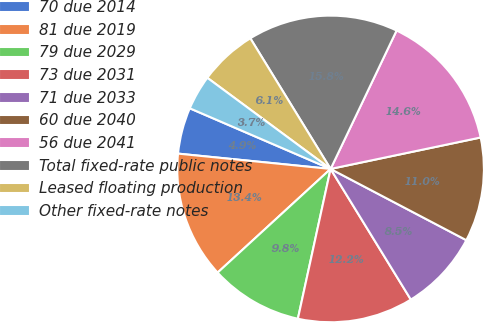<chart> <loc_0><loc_0><loc_500><loc_500><pie_chart><fcel>70 due 2014<fcel>81 due 2019<fcel>79 due 2029<fcel>73 due 2031<fcel>71 due 2033<fcel>60 due 2040<fcel>56 due 2041<fcel>Total fixed-rate public notes<fcel>Leased floating production<fcel>Other fixed-rate notes<nl><fcel>4.88%<fcel>13.41%<fcel>9.76%<fcel>12.19%<fcel>8.54%<fcel>10.98%<fcel>14.63%<fcel>15.85%<fcel>6.1%<fcel>3.66%<nl></chart> 